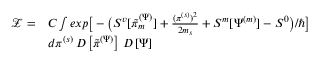Convert formula to latex. <formula><loc_0><loc_0><loc_500><loc_500>\begin{array} { r l } { \mathcal { Z } = } & { C \int e x p \Big [ - \Big ( S ^ { v } [ \tilde { \pi } _ { m } ^ { ( \Psi ) } ] + \frac { ( \pi ^ { ( s ) } ) ^ { 2 } } { 2 m _ { s } } + S ^ { m } [ \Psi ^ { ( m ) } ] - S ^ { 0 } \Big ) / \hbar { \Big } ] } \\ & { d \pi ^ { ( s ) } \, D \left [ \tilde { \pi } ^ { ( \Psi ) } \right ] \, D \left [ \Psi \right ] } \end{array}</formula> 